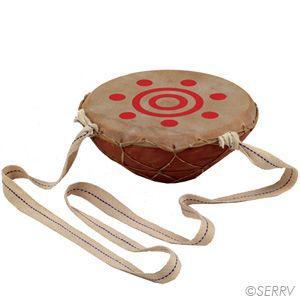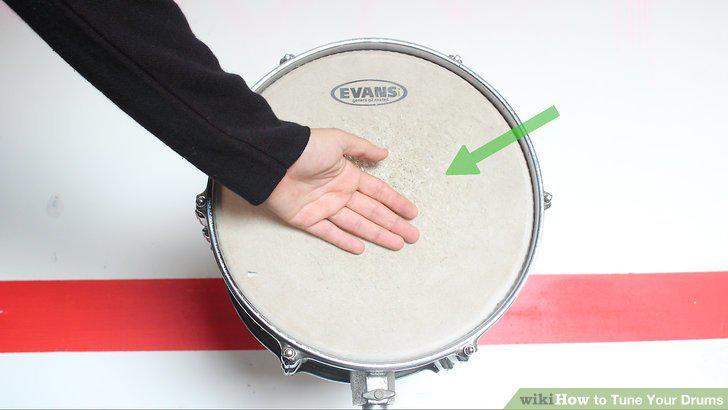The first image is the image on the left, the second image is the image on the right. Assess this claim about the two images: "There are drum sticks in the left image.". Correct or not? Answer yes or no. No. The first image is the image on the left, the second image is the image on the right. Considering the images on both sides, is "The right image shows connected drums with solid-colored sides and white tops, and the left image features two drumsticks and a cylinder shape." valid? Answer yes or no. No. 